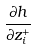Convert formula to latex. <formula><loc_0><loc_0><loc_500><loc_500>\frac { \partial h } { \partial z _ { i } ^ { + } }</formula> 